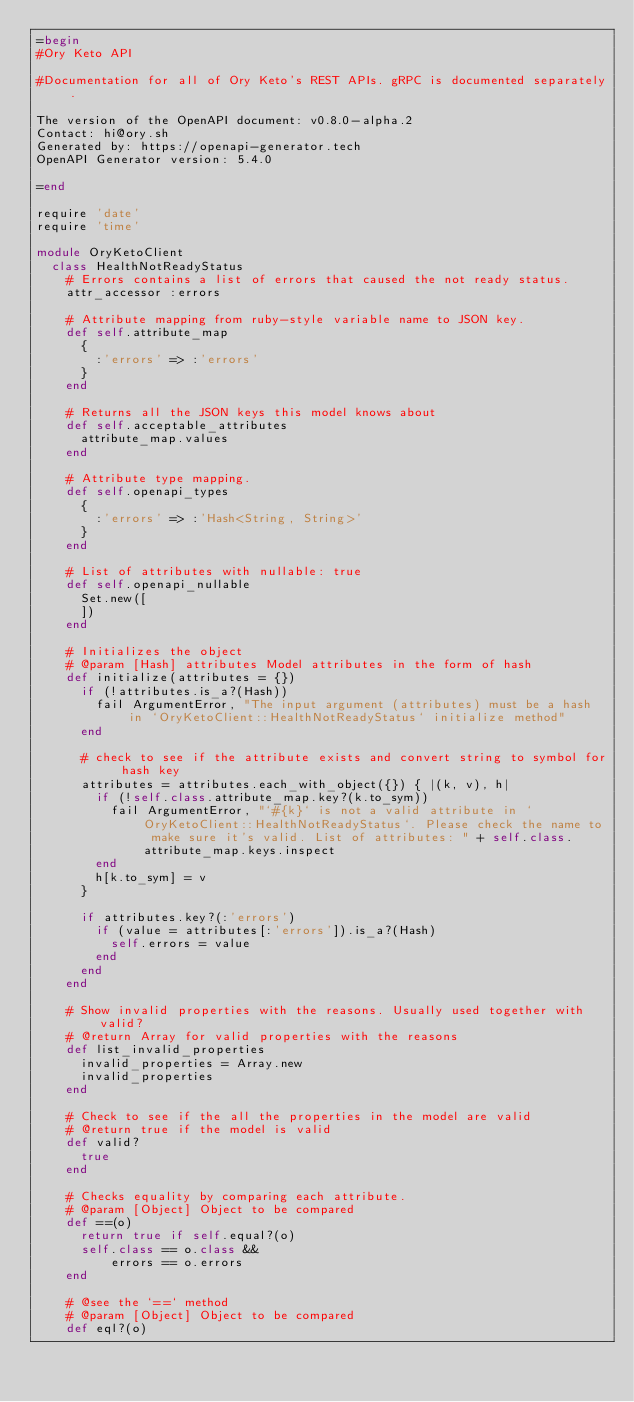Convert code to text. <code><loc_0><loc_0><loc_500><loc_500><_Ruby_>=begin
#Ory Keto API

#Documentation for all of Ory Keto's REST APIs. gRPC is documented separately. 

The version of the OpenAPI document: v0.8.0-alpha.2
Contact: hi@ory.sh
Generated by: https://openapi-generator.tech
OpenAPI Generator version: 5.4.0

=end

require 'date'
require 'time'

module OryKetoClient
  class HealthNotReadyStatus
    # Errors contains a list of errors that caused the not ready status.
    attr_accessor :errors

    # Attribute mapping from ruby-style variable name to JSON key.
    def self.attribute_map
      {
        :'errors' => :'errors'
      }
    end

    # Returns all the JSON keys this model knows about
    def self.acceptable_attributes
      attribute_map.values
    end

    # Attribute type mapping.
    def self.openapi_types
      {
        :'errors' => :'Hash<String, String>'
      }
    end

    # List of attributes with nullable: true
    def self.openapi_nullable
      Set.new([
      ])
    end

    # Initializes the object
    # @param [Hash] attributes Model attributes in the form of hash
    def initialize(attributes = {})
      if (!attributes.is_a?(Hash))
        fail ArgumentError, "The input argument (attributes) must be a hash in `OryKetoClient::HealthNotReadyStatus` initialize method"
      end

      # check to see if the attribute exists and convert string to symbol for hash key
      attributes = attributes.each_with_object({}) { |(k, v), h|
        if (!self.class.attribute_map.key?(k.to_sym))
          fail ArgumentError, "`#{k}` is not a valid attribute in `OryKetoClient::HealthNotReadyStatus`. Please check the name to make sure it's valid. List of attributes: " + self.class.attribute_map.keys.inspect
        end
        h[k.to_sym] = v
      }

      if attributes.key?(:'errors')
        if (value = attributes[:'errors']).is_a?(Hash)
          self.errors = value
        end
      end
    end

    # Show invalid properties with the reasons. Usually used together with valid?
    # @return Array for valid properties with the reasons
    def list_invalid_properties
      invalid_properties = Array.new
      invalid_properties
    end

    # Check to see if the all the properties in the model are valid
    # @return true if the model is valid
    def valid?
      true
    end

    # Checks equality by comparing each attribute.
    # @param [Object] Object to be compared
    def ==(o)
      return true if self.equal?(o)
      self.class == o.class &&
          errors == o.errors
    end

    # @see the `==` method
    # @param [Object] Object to be compared
    def eql?(o)</code> 